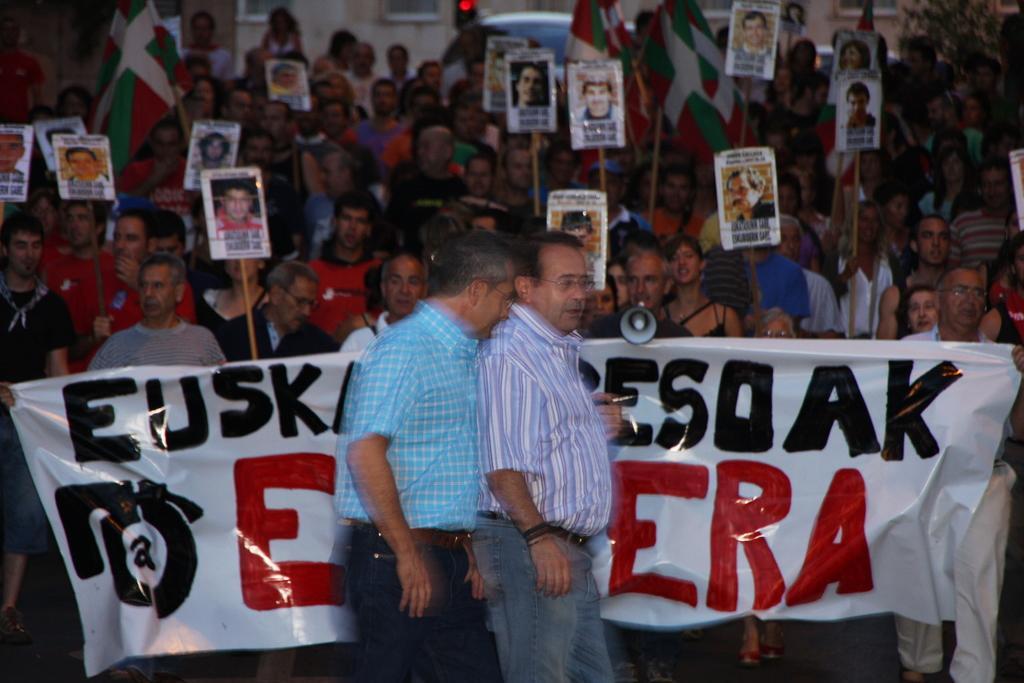In one or two sentences, can you explain what this image depicts? In this image I see number of people in which most of them are holding a board on which there are pictures of persons and few of them are holding flags and few persons over here are holding this banner on which there is something written and this person is holding a megaphone in his hand. 